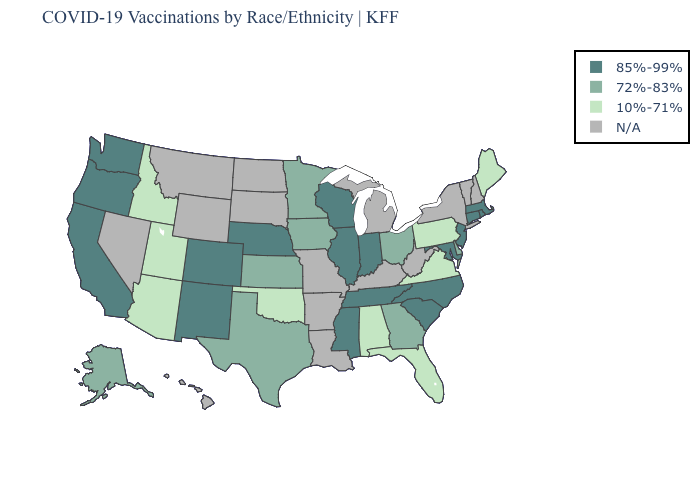What is the value of Iowa?
Keep it brief. 72%-83%. Does the map have missing data?
Answer briefly. Yes. Which states have the lowest value in the USA?
Give a very brief answer. Alabama, Arizona, Florida, Idaho, Maine, Oklahoma, Pennsylvania, Utah, Virginia. Which states have the lowest value in the USA?
Short answer required. Alabama, Arizona, Florida, Idaho, Maine, Oklahoma, Pennsylvania, Utah, Virginia. What is the highest value in the USA?
Answer briefly. 85%-99%. Does Alabama have the lowest value in the USA?
Give a very brief answer. Yes. How many symbols are there in the legend?
Write a very short answer. 4. What is the highest value in the South ?
Be succinct. 85%-99%. What is the value of North Dakota?
Answer briefly. N/A. What is the value of Wisconsin?
Short answer required. 85%-99%. What is the value of Wisconsin?
Give a very brief answer. 85%-99%. Is the legend a continuous bar?
Give a very brief answer. No. Name the states that have a value in the range 72%-83%?
Concise answer only. Alaska, Delaware, Georgia, Iowa, Kansas, Minnesota, Ohio, Texas. What is the value of Alaska?
Be succinct. 72%-83%. 